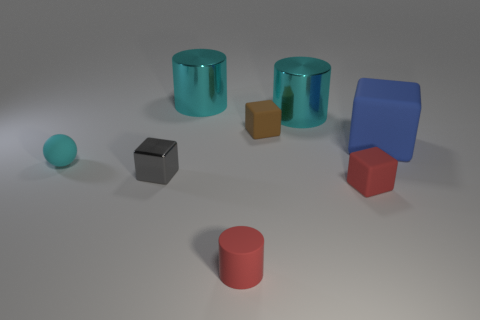What material is the block that is the same color as the tiny cylinder?
Your answer should be very brief. Rubber. Is there anything else that is the same size as the blue block?
Give a very brief answer. Yes. Are there fewer blue blocks that are on the left side of the small gray block than small cyan rubber spheres that are behind the big matte cube?
Your answer should be very brief. No. How many other things are there of the same shape as the gray metal thing?
Offer a terse response. 3. There is a cyan metal object behind the large cyan thing that is to the right of the small rubber cube that is behind the cyan rubber sphere; what size is it?
Keep it short and to the point. Large. What number of cyan things are blocks or small things?
Make the answer very short. 1. There is a big cyan object on the left side of the tiny block behind the rubber ball; what shape is it?
Make the answer very short. Cylinder. There is a rubber thing left of the tiny metallic block; is its size the same as the matte cube in front of the big blue thing?
Provide a short and direct response. Yes. Is there a small object that has the same material as the tiny red cylinder?
Ensure brevity in your answer.  Yes. The object that is the same color as the tiny matte cylinder is what size?
Your answer should be very brief. Small. 